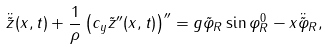<formula> <loc_0><loc_0><loc_500><loc_500>\ddot { \tilde { z } } ( x , t ) + \frac { 1 } { \rho } \left ( c _ { y } { \tilde { z } } ^ { \prime \prime } ( x , t ) \right ) ^ { \prime \prime } = g \tilde { \varphi } _ { R } \sin \varphi _ { R } ^ { 0 } - x \ddot { \tilde { \varphi } } _ { R } ,</formula> 